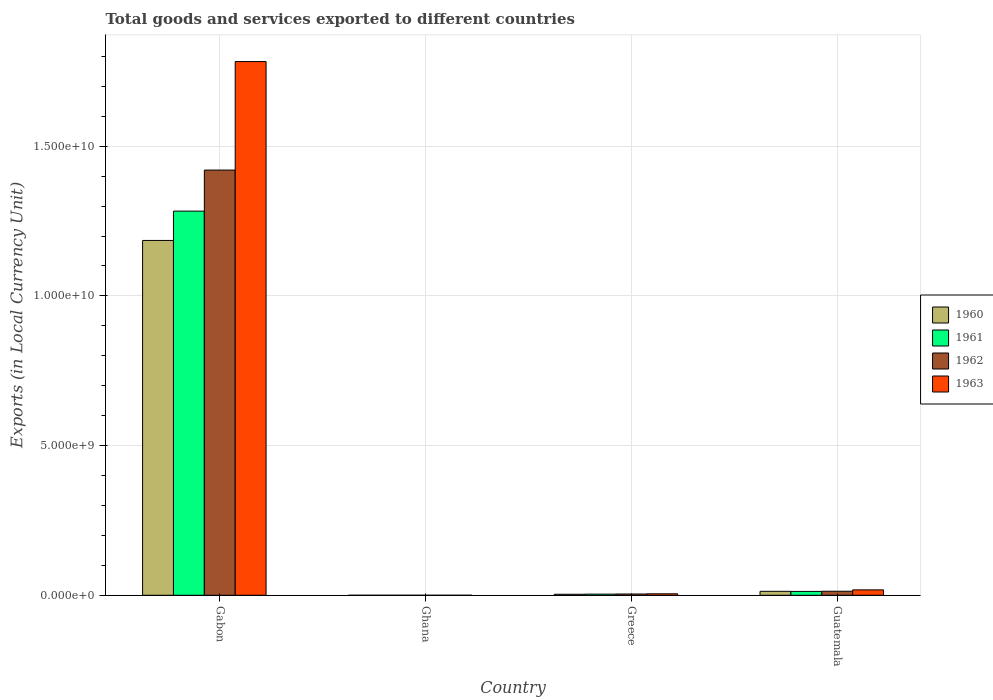How many different coloured bars are there?
Your answer should be very brief. 4. Are the number of bars per tick equal to the number of legend labels?
Offer a terse response. Yes. Are the number of bars on each tick of the X-axis equal?
Provide a short and direct response. Yes. How many bars are there on the 1st tick from the left?
Give a very brief answer. 4. How many bars are there on the 1st tick from the right?
Your answer should be compact. 4. What is the label of the 2nd group of bars from the left?
Your answer should be very brief. Ghana. In how many cases, is the number of bars for a given country not equal to the number of legend labels?
Provide a short and direct response. 0. What is the Amount of goods and services exports in 1962 in Guatemala?
Offer a terse response. 1.35e+08. Across all countries, what is the maximum Amount of goods and services exports in 1961?
Your answer should be very brief. 1.28e+1. Across all countries, what is the minimum Amount of goods and services exports in 1963?
Offer a very short reply. 2.33e+04. In which country was the Amount of goods and services exports in 1963 maximum?
Give a very brief answer. Gabon. In which country was the Amount of goods and services exports in 1960 minimum?
Give a very brief answer. Ghana. What is the total Amount of goods and services exports in 1960 in the graph?
Give a very brief answer. 1.20e+1. What is the difference between the Amount of goods and services exports in 1962 in Gabon and that in Ghana?
Ensure brevity in your answer.  1.42e+1. What is the difference between the Amount of goods and services exports in 1962 in Greece and the Amount of goods and services exports in 1963 in Gabon?
Offer a very short reply. -1.78e+1. What is the average Amount of goods and services exports in 1962 per country?
Give a very brief answer. 3.60e+09. What is the difference between the Amount of goods and services exports of/in 1961 and Amount of goods and services exports of/in 1962 in Gabon?
Your response must be concise. -1.37e+09. What is the ratio of the Amount of goods and services exports in 1960 in Ghana to that in Greece?
Your answer should be very brief. 0. Is the Amount of goods and services exports in 1960 in Greece less than that in Guatemala?
Your answer should be compact. Yes. What is the difference between the highest and the second highest Amount of goods and services exports in 1963?
Give a very brief answer. 1.31e+08. What is the difference between the highest and the lowest Amount of goods and services exports in 1962?
Provide a succinct answer. 1.42e+1. Is the sum of the Amount of goods and services exports in 1963 in Gabon and Ghana greater than the maximum Amount of goods and services exports in 1962 across all countries?
Provide a succinct answer. Yes. What does the 2nd bar from the right in Guatemala represents?
Your response must be concise. 1962. How many countries are there in the graph?
Your response must be concise. 4. What is the difference between two consecutive major ticks on the Y-axis?
Your answer should be compact. 5.00e+09. Are the values on the major ticks of Y-axis written in scientific E-notation?
Offer a very short reply. Yes. Does the graph contain grids?
Ensure brevity in your answer.  Yes. How are the legend labels stacked?
Give a very brief answer. Vertical. What is the title of the graph?
Provide a succinct answer. Total goods and services exported to different countries. What is the label or title of the X-axis?
Make the answer very short. Country. What is the label or title of the Y-axis?
Offer a terse response. Exports (in Local Currency Unit). What is the Exports (in Local Currency Unit) of 1960 in Gabon?
Make the answer very short. 1.19e+1. What is the Exports (in Local Currency Unit) in 1961 in Gabon?
Provide a succinct answer. 1.28e+1. What is the Exports (in Local Currency Unit) in 1962 in Gabon?
Keep it short and to the point. 1.42e+1. What is the Exports (in Local Currency Unit) in 1963 in Gabon?
Offer a very short reply. 1.78e+1. What is the Exports (in Local Currency Unit) of 1960 in Ghana?
Your answer should be compact. 2.45e+04. What is the Exports (in Local Currency Unit) of 1961 in Ghana?
Your answer should be very brief. 2.43e+04. What is the Exports (in Local Currency Unit) of 1962 in Ghana?
Provide a succinct answer. 2.39e+04. What is the Exports (in Local Currency Unit) in 1963 in Ghana?
Give a very brief answer. 2.33e+04. What is the Exports (in Local Currency Unit) in 1960 in Greece?
Provide a short and direct response. 3.33e+07. What is the Exports (in Local Currency Unit) in 1961 in Greece?
Give a very brief answer. 3.82e+07. What is the Exports (in Local Currency Unit) of 1962 in Greece?
Keep it short and to the point. 4.25e+07. What is the Exports (in Local Currency Unit) of 1963 in Greece?
Your answer should be compact. 4.90e+07. What is the Exports (in Local Currency Unit) in 1960 in Guatemala?
Keep it short and to the point. 1.32e+08. What is the Exports (in Local Currency Unit) in 1961 in Guatemala?
Your response must be concise. 1.29e+08. What is the Exports (in Local Currency Unit) in 1962 in Guatemala?
Ensure brevity in your answer.  1.35e+08. What is the Exports (in Local Currency Unit) of 1963 in Guatemala?
Ensure brevity in your answer.  1.80e+08. Across all countries, what is the maximum Exports (in Local Currency Unit) in 1960?
Ensure brevity in your answer.  1.19e+1. Across all countries, what is the maximum Exports (in Local Currency Unit) in 1961?
Ensure brevity in your answer.  1.28e+1. Across all countries, what is the maximum Exports (in Local Currency Unit) in 1962?
Provide a short and direct response. 1.42e+1. Across all countries, what is the maximum Exports (in Local Currency Unit) of 1963?
Ensure brevity in your answer.  1.78e+1. Across all countries, what is the minimum Exports (in Local Currency Unit) of 1960?
Make the answer very short. 2.45e+04. Across all countries, what is the minimum Exports (in Local Currency Unit) of 1961?
Your response must be concise. 2.43e+04. Across all countries, what is the minimum Exports (in Local Currency Unit) of 1962?
Your answer should be very brief. 2.39e+04. Across all countries, what is the minimum Exports (in Local Currency Unit) in 1963?
Your answer should be compact. 2.33e+04. What is the total Exports (in Local Currency Unit) of 1960 in the graph?
Your answer should be very brief. 1.20e+1. What is the total Exports (in Local Currency Unit) of 1961 in the graph?
Your answer should be very brief. 1.30e+1. What is the total Exports (in Local Currency Unit) in 1962 in the graph?
Offer a terse response. 1.44e+1. What is the total Exports (in Local Currency Unit) in 1963 in the graph?
Provide a succinct answer. 1.81e+1. What is the difference between the Exports (in Local Currency Unit) of 1960 in Gabon and that in Ghana?
Ensure brevity in your answer.  1.19e+1. What is the difference between the Exports (in Local Currency Unit) in 1961 in Gabon and that in Ghana?
Keep it short and to the point. 1.28e+1. What is the difference between the Exports (in Local Currency Unit) of 1962 in Gabon and that in Ghana?
Give a very brief answer. 1.42e+1. What is the difference between the Exports (in Local Currency Unit) in 1963 in Gabon and that in Ghana?
Offer a very short reply. 1.78e+1. What is the difference between the Exports (in Local Currency Unit) of 1960 in Gabon and that in Greece?
Keep it short and to the point. 1.18e+1. What is the difference between the Exports (in Local Currency Unit) in 1961 in Gabon and that in Greece?
Make the answer very short. 1.28e+1. What is the difference between the Exports (in Local Currency Unit) in 1962 in Gabon and that in Greece?
Your answer should be compact. 1.42e+1. What is the difference between the Exports (in Local Currency Unit) in 1963 in Gabon and that in Greece?
Ensure brevity in your answer.  1.78e+1. What is the difference between the Exports (in Local Currency Unit) of 1960 in Gabon and that in Guatemala?
Keep it short and to the point. 1.17e+1. What is the difference between the Exports (in Local Currency Unit) of 1961 in Gabon and that in Guatemala?
Offer a very short reply. 1.27e+1. What is the difference between the Exports (in Local Currency Unit) of 1962 in Gabon and that in Guatemala?
Provide a short and direct response. 1.41e+1. What is the difference between the Exports (in Local Currency Unit) in 1963 in Gabon and that in Guatemala?
Give a very brief answer. 1.76e+1. What is the difference between the Exports (in Local Currency Unit) of 1960 in Ghana and that in Greece?
Offer a very short reply. -3.33e+07. What is the difference between the Exports (in Local Currency Unit) of 1961 in Ghana and that in Greece?
Your answer should be compact. -3.82e+07. What is the difference between the Exports (in Local Currency Unit) in 1962 in Ghana and that in Greece?
Give a very brief answer. -4.25e+07. What is the difference between the Exports (in Local Currency Unit) in 1963 in Ghana and that in Greece?
Make the answer very short. -4.90e+07. What is the difference between the Exports (in Local Currency Unit) in 1960 in Ghana and that in Guatemala?
Make the answer very short. -1.32e+08. What is the difference between the Exports (in Local Currency Unit) in 1961 in Ghana and that in Guatemala?
Ensure brevity in your answer.  -1.29e+08. What is the difference between the Exports (in Local Currency Unit) in 1962 in Ghana and that in Guatemala?
Offer a very short reply. -1.35e+08. What is the difference between the Exports (in Local Currency Unit) of 1963 in Ghana and that in Guatemala?
Your response must be concise. -1.80e+08. What is the difference between the Exports (in Local Currency Unit) of 1960 in Greece and that in Guatemala?
Provide a short and direct response. -9.86e+07. What is the difference between the Exports (in Local Currency Unit) of 1961 in Greece and that in Guatemala?
Offer a terse response. -9.05e+07. What is the difference between the Exports (in Local Currency Unit) of 1962 in Greece and that in Guatemala?
Provide a succinct answer. -9.23e+07. What is the difference between the Exports (in Local Currency Unit) in 1963 in Greece and that in Guatemala?
Your answer should be very brief. -1.31e+08. What is the difference between the Exports (in Local Currency Unit) in 1960 in Gabon and the Exports (in Local Currency Unit) in 1961 in Ghana?
Your answer should be compact. 1.19e+1. What is the difference between the Exports (in Local Currency Unit) in 1960 in Gabon and the Exports (in Local Currency Unit) in 1962 in Ghana?
Offer a very short reply. 1.19e+1. What is the difference between the Exports (in Local Currency Unit) of 1960 in Gabon and the Exports (in Local Currency Unit) of 1963 in Ghana?
Offer a very short reply. 1.19e+1. What is the difference between the Exports (in Local Currency Unit) in 1961 in Gabon and the Exports (in Local Currency Unit) in 1962 in Ghana?
Make the answer very short. 1.28e+1. What is the difference between the Exports (in Local Currency Unit) of 1961 in Gabon and the Exports (in Local Currency Unit) of 1963 in Ghana?
Keep it short and to the point. 1.28e+1. What is the difference between the Exports (in Local Currency Unit) in 1962 in Gabon and the Exports (in Local Currency Unit) in 1963 in Ghana?
Give a very brief answer. 1.42e+1. What is the difference between the Exports (in Local Currency Unit) of 1960 in Gabon and the Exports (in Local Currency Unit) of 1961 in Greece?
Provide a short and direct response. 1.18e+1. What is the difference between the Exports (in Local Currency Unit) of 1960 in Gabon and the Exports (in Local Currency Unit) of 1962 in Greece?
Ensure brevity in your answer.  1.18e+1. What is the difference between the Exports (in Local Currency Unit) of 1960 in Gabon and the Exports (in Local Currency Unit) of 1963 in Greece?
Make the answer very short. 1.18e+1. What is the difference between the Exports (in Local Currency Unit) in 1961 in Gabon and the Exports (in Local Currency Unit) in 1962 in Greece?
Your answer should be compact. 1.28e+1. What is the difference between the Exports (in Local Currency Unit) in 1961 in Gabon and the Exports (in Local Currency Unit) in 1963 in Greece?
Your answer should be very brief. 1.28e+1. What is the difference between the Exports (in Local Currency Unit) of 1962 in Gabon and the Exports (in Local Currency Unit) of 1963 in Greece?
Offer a terse response. 1.42e+1. What is the difference between the Exports (in Local Currency Unit) of 1960 in Gabon and the Exports (in Local Currency Unit) of 1961 in Guatemala?
Provide a short and direct response. 1.17e+1. What is the difference between the Exports (in Local Currency Unit) in 1960 in Gabon and the Exports (in Local Currency Unit) in 1962 in Guatemala?
Offer a very short reply. 1.17e+1. What is the difference between the Exports (in Local Currency Unit) in 1960 in Gabon and the Exports (in Local Currency Unit) in 1963 in Guatemala?
Provide a short and direct response. 1.17e+1. What is the difference between the Exports (in Local Currency Unit) of 1961 in Gabon and the Exports (in Local Currency Unit) of 1962 in Guatemala?
Your answer should be very brief. 1.27e+1. What is the difference between the Exports (in Local Currency Unit) of 1961 in Gabon and the Exports (in Local Currency Unit) of 1963 in Guatemala?
Offer a terse response. 1.27e+1. What is the difference between the Exports (in Local Currency Unit) in 1962 in Gabon and the Exports (in Local Currency Unit) in 1963 in Guatemala?
Your answer should be compact. 1.40e+1. What is the difference between the Exports (in Local Currency Unit) in 1960 in Ghana and the Exports (in Local Currency Unit) in 1961 in Greece?
Provide a succinct answer. -3.82e+07. What is the difference between the Exports (in Local Currency Unit) of 1960 in Ghana and the Exports (in Local Currency Unit) of 1962 in Greece?
Your response must be concise. -4.25e+07. What is the difference between the Exports (in Local Currency Unit) of 1960 in Ghana and the Exports (in Local Currency Unit) of 1963 in Greece?
Offer a very short reply. -4.90e+07. What is the difference between the Exports (in Local Currency Unit) of 1961 in Ghana and the Exports (in Local Currency Unit) of 1962 in Greece?
Make the answer very short. -4.25e+07. What is the difference between the Exports (in Local Currency Unit) in 1961 in Ghana and the Exports (in Local Currency Unit) in 1963 in Greece?
Your answer should be compact. -4.90e+07. What is the difference between the Exports (in Local Currency Unit) in 1962 in Ghana and the Exports (in Local Currency Unit) in 1963 in Greece?
Give a very brief answer. -4.90e+07. What is the difference between the Exports (in Local Currency Unit) in 1960 in Ghana and the Exports (in Local Currency Unit) in 1961 in Guatemala?
Offer a very short reply. -1.29e+08. What is the difference between the Exports (in Local Currency Unit) of 1960 in Ghana and the Exports (in Local Currency Unit) of 1962 in Guatemala?
Offer a terse response. -1.35e+08. What is the difference between the Exports (in Local Currency Unit) of 1960 in Ghana and the Exports (in Local Currency Unit) of 1963 in Guatemala?
Keep it short and to the point. -1.80e+08. What is the difference between the Exports (in Local Currency Unit) of 1961 in Ghana and the Exports (in Local Currency Unit) of 1962 in Guatemala?
Keep it short and to the point. -1.35e+08. What is the difference between the Exports (in Local Currency Unit) in 1961 in Ghana and the Exports (in Local Currency Unit) in 1963 in Guatemala?
Make the answer very short. -1.80e+08. What is the difference between the Exports (in Local Currency Unit) of 1962 in Ghana and the Exports (in Local Currency Unit) of 1963 in Guatemala?
Your answer should be very brief. -1.80e+08. What is the difference between the Exports (in Local Currency Unit) in 1960 in Greece and the Exports (in Local Currency Unit) in 1961 in Guatemala?
Provide a succinct answer. -9.54e+07. What is the difference between the Exports (in Local Currency Unit) of 1960 in Greece and the Exports (in Local Currency Unit) of 1962 in Guatemala?
Give a very brief answer. -1.01e+08. What is the difference between the Exports (in Local Currency Unit) in 1960 in Greece and the Exports (in Local Currency Unit) in 1963 in Guatemala?
Offer a terse response. -1.47e+08. What is the difference between the Exports (in Local Currency Unit) in 1961 in Greece and the Exports (in Local Currency Unit) in 1962 in Guatemala?
Your response must be concise. -9.66e+07. What is the difference between the Exports (in Local Currency Unit) in 1961 in Greece and the Exports (in Local Currency Unit) in 1963 in Guatemala?
Your answer should be compact. -1.42e+08. What is the difference between the Exports (in Local Currency Unit) in 1962 in Greece and the Exports (in Local Currency Unit) in 1963 in Guatemala?
Ensure brevity in your answer.  -1.38e+08. What is the average Exports (in Local Currency Unit) of 1960 per country?
Ensure brevity in your answer.  3.00e+09. What is the average Exports (in Local Currency Unit) in 1961 per country?
Provide a succinct answer. 3.25e+09. What is the average Exports (in Local Currency Unit) in 1962 per country?
Keep it short and to the point. 3.60e+09. What is the average Exports (in Local Currency Unit) of 1963 per country?
Give a very brief answer. 4.51e+09. What is the difference between the Exports (in Local Currency Unit) in 1960 and Exports (in Local Currency Unit) in 1961 in Gabon?
Provide a short and direct response. -9.80e+08. What is the difference between the Exports (in Local Currency Unit) of 1960 and Exports (in Local Currency Unit) of 1962 in Gabon?
Keep it short and to the point. -2.35e+09. What is the difference between the Exports (in Local Currency Unit) of 1960 and Exports (in Local Currency Unit) of 1963 in Gabon?
Your answer should be compact. -5.98e+09. What is the difference between the Exports (in Local Currency Unit) of 1961 and Exports (in Local Currency Unit) of 1962 in Gabon?
Your answer should be very brief. -1.37e+09. What is the difference between the Exports (in Local Currency Unit) in 1961 and Exports (in Local Currency Unit) in 1963 in Gabon?
Provide a succinct answer. -5.00e+09. What is the difference between the Exports (in Local Currency Unit) in 1962 and Exports (in Local Currency Unit) in 1963 in Gabon?
Ensure brevity in your answer.  -3.62e+09. What is the difference between the Exports (in Local Currency Unit) in 1960 and Exports (in Local Currency Unit) in 1962 in Ghana?
Offer a terse response. 600. What is the difference between the Exports (in Local Currency Unit) of 1960 and Exports (in Local Currency Unit) of 1963 in Ghana?
Make the answer very short. 1200. What is the difference between the Exports (in Local Currency Unit) in 1961 and Exports (in Local Currency Unit) in 1962 in Ghana?
Give a very brief answer. 400. What is the difference between the Exports (in Local Currency Unit) of 1962 and Exports (in Local Currency Unit) of 1963 in Ghana?
Ensure brevity in your answer.  600. What is the difference between the Exports (in Local Currency Unit) of 1960 and Exports (in Local Currency Unit) of 1961 in Greece?
Make the answer very short. -4.90e+06. What is the difference between the Exports (in Local Currency Unit) of 1960 and Exports (in Local Currency Unit) of 1962 in Greece?
Keep it short and to the point. -9.19e+06. What is the difference between the Exports (in Local Currency Unit) of 1960 and Exports (in Local Currency Unit) of 1963 in Greece?
Offer a very short reply. -1.57e+07. What is the difference between the Exports (in Local Currency Unit) in 1961 and Exports (in Local Currency Unit) in 1962 in Greece?
Ensure brevity in your answer.  -4.29e+06. What is the difference between the Exports (in Local Currency Unit) in 1961 and Exports (in Local Currency Unit) in 1963 in Greece?
Keep it short and to the point. -1.08e+07. What is the difference between the Exports (in Local Currency Unit) in 1962 and Exports (in Local Currency Unit) in 1963 in Greece?
Provide a short and direct response. -6.47e+06. What is the difference between the Exports (in Local Currency Unit) in 1960 and Exports (in Local Currency Unit) in 1961 in Guatemala?
Provide a short and direct response. 3.20e+06. What is the difference between the Exports (in Local Currency Unit) of 1960 and Exports (in Local Currency Unit) of 1962 in Guatemala?
Provide a short and direct response. -2.90e+06. What is the difference between the Exports (in Local Currency Unit) of 1960 and Exports (in Local Currency Unit) of 1963 in Guatemala?
Keep it short and to the point. -4.85e+07. What is the difference between the Exports (in Local Currency Unit) of 1961 and Exports (in Local Currency Unit) of 1962 in Guatemala?
Your response must be concise. -6.10e+06. What is the difference between the Exports (in Local Currency Unit) in 1961 and Exports (in Local Currency Unit) in 1963 in Guatemala?
Your answer should be compact. -5.17e+07. What is the difference between the Exports (in Local Currency Unit) in 1962 and Exports (in Local Currency Unit) in 1963 in Guatemala?
Offer a very short reply. -4.56e+07. What is the ratio of the Exports (in Local Currency Unit) in 1960 in Gabon to that in Ghana?
Your answer should be compact. 4.84e+05. What is the ratio of the Exports (in Local Currency Unit) of 1961 in Gabon to that in Ghana?
Offer a terse response. 5.28e+05. What is the ratio of the Exports (in Local Currency Unit) of 1962 in Gabon to that in Ghana?
Provide a short and direct response. 5.94e+05. What is the ratio of the Exports (in Local Currency Unit) of 1963 in Gabon to that in Ghana?
Ensure brevity in your answer.  7.65e+05. What is the ratio of the Exports (in Local Currency Unit) in 1960 in Gabon to that in Greece?
Offer a very short reply. 355.72. What is the ratio of the Exports (in Local Currency Unit) of 1961 in Gabon to that in Greece?
Provide a succinct answer. 335.76. What is the ratio of the Exports (in Local Currency Unit) in 1962 in Gabon to that in Greece?
Your response must be concise. 334.16. What is the ratio of the Exports (in Local Currency Unit) of 1963 in Gabon to that in Greece?
Make the answer very short. 364.01. What is the ratio of the Exports (in Local Currency Unit) of 1960 in Gabon to that in Guatemala?
Your answer should be very brief. 89.86. What is the ratio of the Exports (in Local Currency Unit) of 1961 in Gabon to that in Guatemala?
Ensure brevity in your answer.  99.71. What is the ratio of the Exports (in Local Currency Unit) in 1962 in Gabon to that in Guatemala?
Give a very brief answer. 105.37. What is the ratio of the Exports (in Local Currency Unit) of 1963 in Gabon to that in Guatemala?
Ensure brevity in your answer.  98.83. What is the ratio of the Exports (in Local Currency Unit) in 1960 in Ghana to that in Greece?
Your response must be concise. 0. What is the ratio of the Exports (in Local Currency Unit) in 1961 in Ghana to that in Greece?
Your answer should be very brief. 0. What is the ratio of the Exports (in Local Currency Unit) in 1962 in Ghana to that in Greece?
Give a very brief answer. 0. What is the ratio of the Exports (in Local Currency Unit) in 1963 in Ghana to that in Greece?
Your answer should be very brief. 0. What is the ratio of the Exports (in Local Currency Unit) of 1961 in Ghana to that in Guatemala?
Keep it short and to the point. 0. What is the ratio of the Exports (in Local Currency Unit) in 1963 in Ghana to that in Guatemala?
Provide a succinct answer. 0. What is the ratio of the Exports (in Local Currency Unit) in 1960 in Greece to that in Guatemala?
Offer a terse response. 0.25. What is the ratio of the Exports (in Local Currency Unit) of 1961 in Greece to that in Guatemala?
Your answer should be very brief. 0.3. What is the ratio of the Exports (in Local Currency Unit) in 1962 in Greece to that in Guatemala?
Offer a very short reply. 0.32. What is the ratio of the Exports (in Local Currency Unit) of 1963 in Greece to that in Guatemala?
Keep it short and to the point. 0.27. What is the difference between the highest and the second highest Exports (in Local Currency Unit) of 1960?
Your answer should be very brief. 1.17e+1. What is the difference between the highest and the second highest Exports (in Local Currency Unit) of 1961?
Provide a short and direct response. 1.27e+1. What is the difference between the highest and the second highest Exports (in Local Currency Unit) in 1962?
Ensure brevity in your answer.  1.41e+1. What is the difference between the highest and the second highest Exports (in Local Currency Unit) of 1963?
Your answer should be compact. 1.76e+1. What is the difference between the highest and the lowest Exports (in Local Currency Unit) of 1960?
Provide a short and direct response. 1.19e+1. What is the difference between the highest and the lowest Exports (in Local Currency Unit) in 1961?
Keep it short and to the point. 1.28e+1. What is the difference between the highest and the lowest Exports (in Local Currency Unit) in 1962?
Your answer should be very brief. 1.42e+1. What is the difference between the highest and the lowest Exports (in Local Currency Unit) in 1963?
Your answer should be compact. 1.78e+1. 